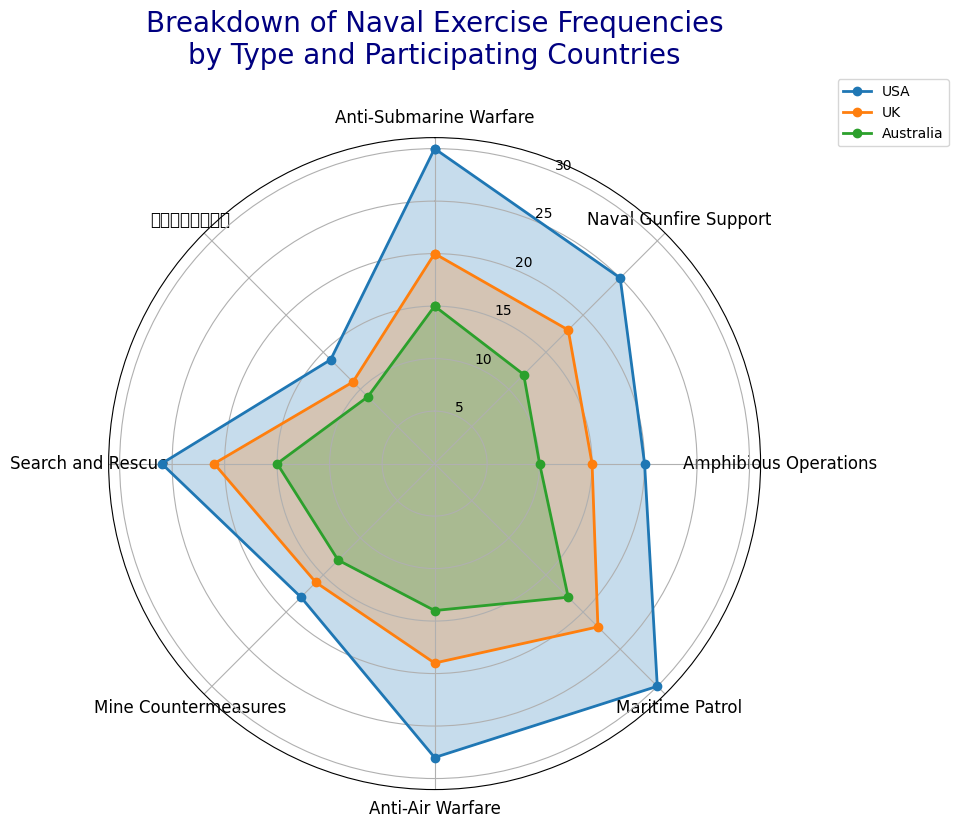Which exercise type does the USA participate in most frequently? The rose chart shows the breakdown of frequencies for the USA in different exercise types. By looking at the lengths of the colored sections representing the USA, Maritime Patrol (in blue color and extending the furthest) has the highest frequency at 30.
Answer: Maritime Patrol How does the frequency of Anti-Submarine Warfare exercises compare between the UK and Australia? We look at the lengths of the segments for Anti-Submarine Warfare exercises for both the UK and Australia. The UK section is slightly longer than Australia, with frequencies of 20 and 15 respectively.
Answer: UK > Australia Which country participates in Search and Rescue exercises the most? We examine the sections for Search and Rescue exercises across different countries. The longest section representing Search and Rescue belongs to the USA, with a frequency of 26.
Answer: USA What is the difference in frequency between the highest and lowest participating countries in Naval Gunfire Support exercises? The USA has the highest frequency at 25 and Australia has the lowest at 12. The difference is calculated by subtracting Australia's value from the USA's value (25 - 12).
Answer: 13 Which exercise type has relatively equal participation across all three countries? A visual inspection of the lengths of the segments for different exercise types shows that amphibious operations have relatively equal segment lengths, with the frequencies being 20, 15, and 10 for the USA, UK, and Australia respectively.
Answer: Amphibious Operations What is the average frequency of Mine Countermeasures across all countries? The frequencies for Mine Countermeasures for the USA, UK, and Australia are 18, 16, and 13 respectively. The average is calculated by summing these values (18 + 16 + 13 = 47) and dividing by the number of countries (47 / 3).
Answer: 15.67 For which Exercise Type is UK’s participation the highest? By examining the lengths of the sections for the UK, the longest segment corresponds to Maritime Patrol with a frequency of 22.
Answer: Maritime Patrol Compare the total frequency of exercises involving the USA and Australia. Summing up the frequencies of all exercise types for USA (30+25+20+30+28+18+26+14 = 191) and Australia (15+12+10+18+14+13+15+9 = 106), the total frequencies are compared.
Answer: USA > Australia Considering Anti-Air Warfare and Search and Rescue exercises, which one has a higher combined frequency for all countries? Adding up the frequencies for all countries in Anti-Air Warfare (28+19+14 = 61) and Search and Rescue (26+21+15 = 62), we then compare the combined totals.
Answer: Search and Rescue Which exercise type does Australia participate in the least? The least participated exercise type by Australia has the shortest segment in the rose chart, showing a frequency of 9 for the exercise type with Chinese characters (舰队保险计划演习).
Answer: 舰队保险计划演习 